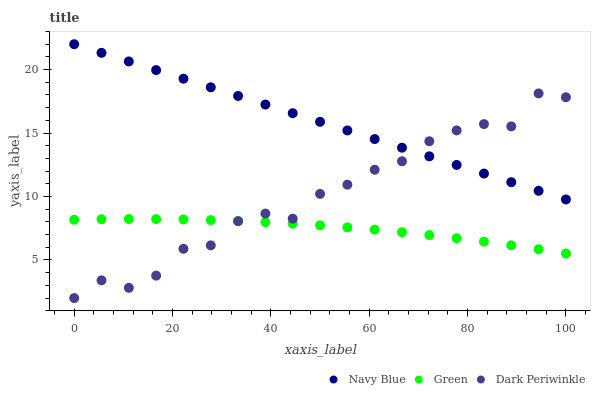Does Green have the minimum area under the curve?
Answer yes or no. Yes. Does Navy Blue have the maximum area under the curve?
Answer yes or no. Yes. Does Dark Periwinkle have the minimum area under the curve?
Answer yes or no. No. Does Dark Periwinkle have the maximum area under the curve?
Answer yes or no. No. Is Navy Blue the smoothest?
Answer yes or no. Yes. Is Dark Periwinkle the roughest?
Answer yes or no. Yes. Is Green the smoothest?
Answer yes or no. No. Is Green the roughest?
Answer yes or no. No. Does Dark Periwinkle have the lowest value?
Answer yes or no. Yes. Does Green have the lowest value?
Answer yes or no. No. Does Navy Blue have the highest value?
Answer yes or no. Yes. Does Dark Periwinkle have the highest value?
Answer yes or no. No. Is Green less than Navy Blue?
Answer yes or no. Yes. Is Navy Blue greater than Green?
Answer yes or no. Yes. Does Navy Blue intersect Dark Periwinkle?
Answer yes or no. Yes. Is Navy Blue less than Dark Periwinkle?
Answer yes or no. No. Is Navy Blue greater than Dark Periwinkle?
Answer yes or no. No. Does Green intersect Navy Blue?
Answer yes or no. No. 